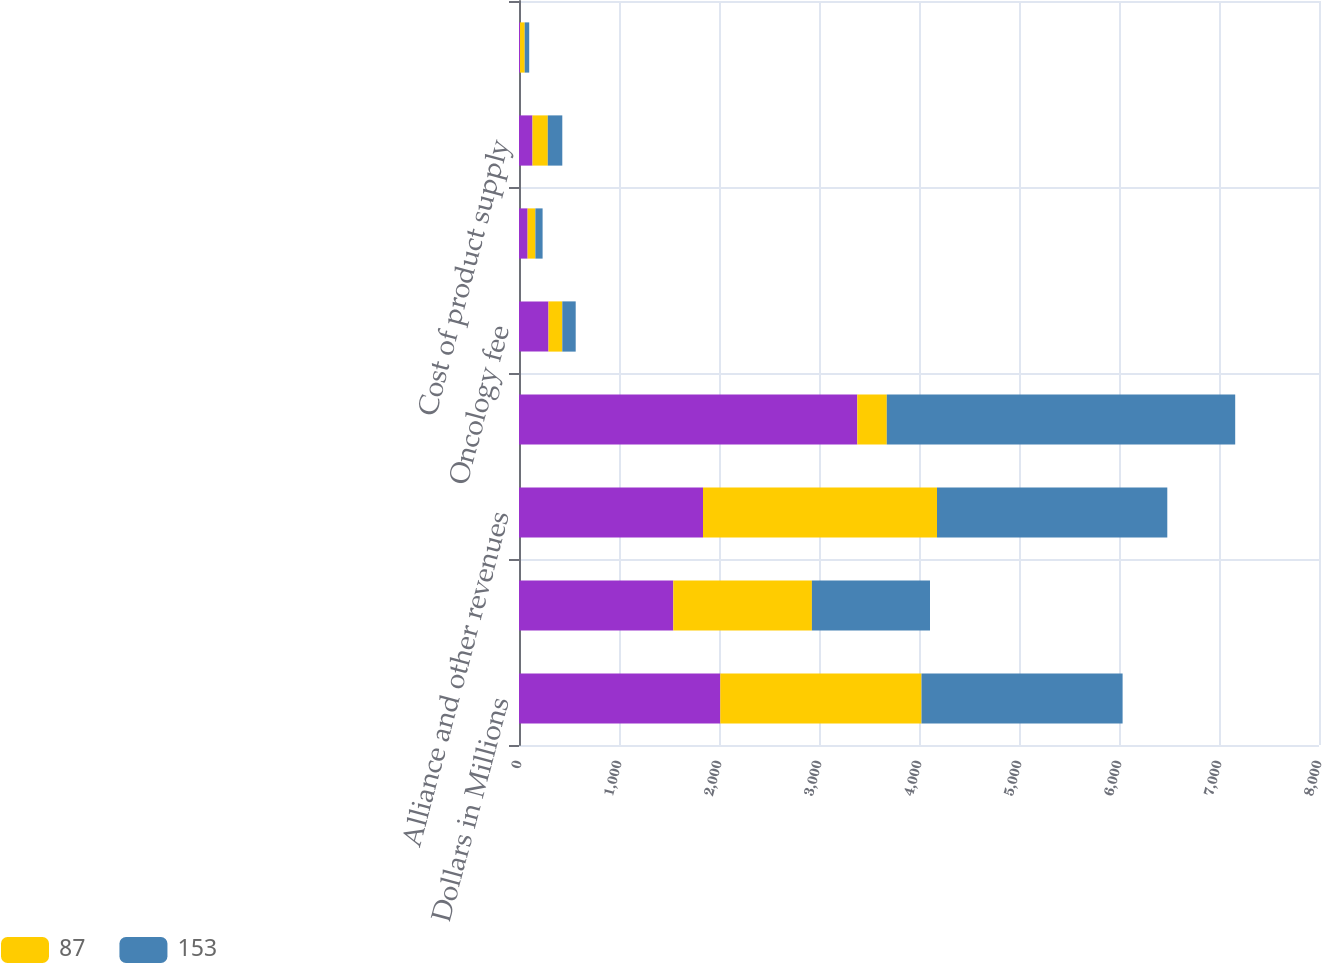<chart> <loc_0><loc_0><loc_500><loc_500><stacked_bar_chart><ecel><fcel>Dollars in Millions<fcel>Net product sales<fcel>Alliance and other revenues<fcel>Total Revenues<fcel>Oncology fee<fcel>Royalties<fcel>Cost of product supply<fcel>Cost reimbursements to/(from)<nl><fcel>nan<fcel>2013<fcel>1543<fcel>1840<fcel>3383<fcel>295<fcel>86<fcel>135<fcel>10<nl><fcel>87<fcel>2012<fcel>1386<fcel>2340<fcel>295<fcel>138<fcel>78<fcel>153<fcel>47<nl><fcel>153<fcel>2011<fcel>1181<fcel>2303<fcel>3484<fcel>134<fcel>72<fcel>145<fcel>45<nl></chart> 